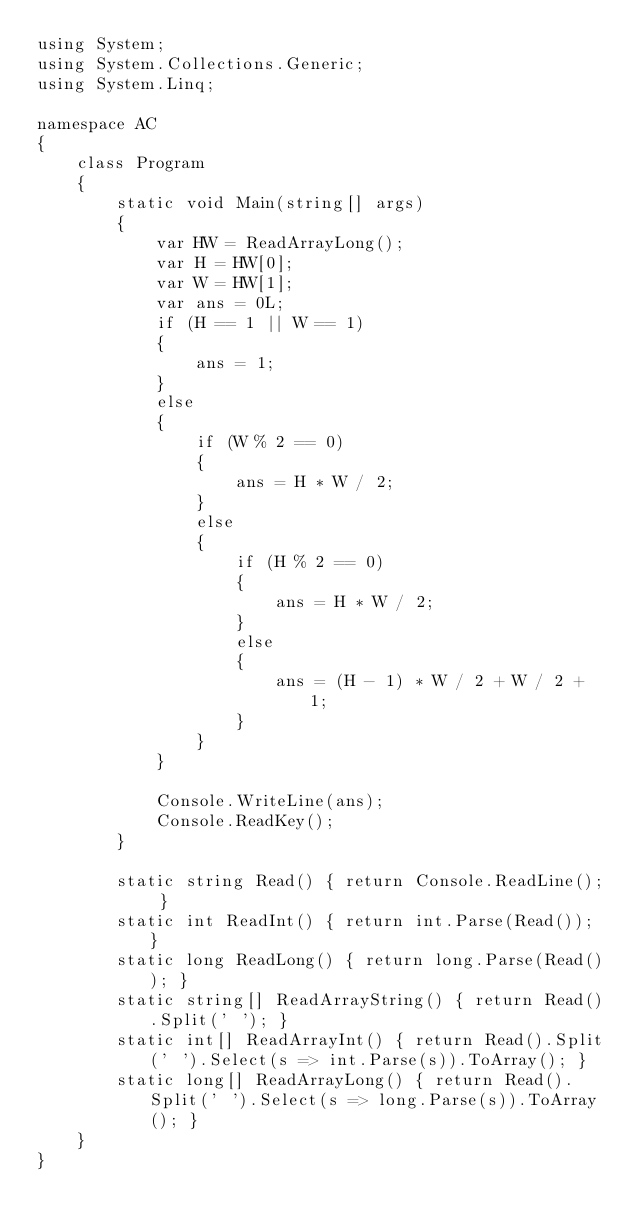Convert code to text. <code><loc_0><loc_0><loc_500><loc_500><_C#_>using System;
using System.Collections.Generic;
using System.Linq;

namespace AC
{
    class Program
    {
        static void Main(string[] args)
        {
            var HW = ReadArrayLong();
            var H = HW[0];
            var W = HW[1];
            var ans = 0L;
            if (H == 1 || W == 1)
            {
                ans = 1;
            }
            else
            {
                if (W % 2 == 0)
                {
                    ans = H * W / 2;
                }
                else
                {
                    if (H % 2 == 0)
                    {
                        ans = H * W / 2;
                    }
                    else
                    {
                        ans = (H - 1) * W / 2 + W / 2 + 1;
                    }
                }
            }

            Console.WriteLine(ans);
            Console.ReadKey();
        }

        static string Read() { return Console.ReadLine(); }
        static int ReadInt() { return int.Parse(Read()); }
        static long ReadLong() { return long.Parse(Read()); }
        static string[] ReadArrayString() { return Read().Split(' '); }
        static int[] ReadArrayInt() { return Read().Split(' ').Select(s => int.Parse(s)).ToArray(); }
        static long[] ReadArrayLong() { return Read().Split(' ').Select(s => long.Parse(s)).ToArray(); }
    }
}</code> 